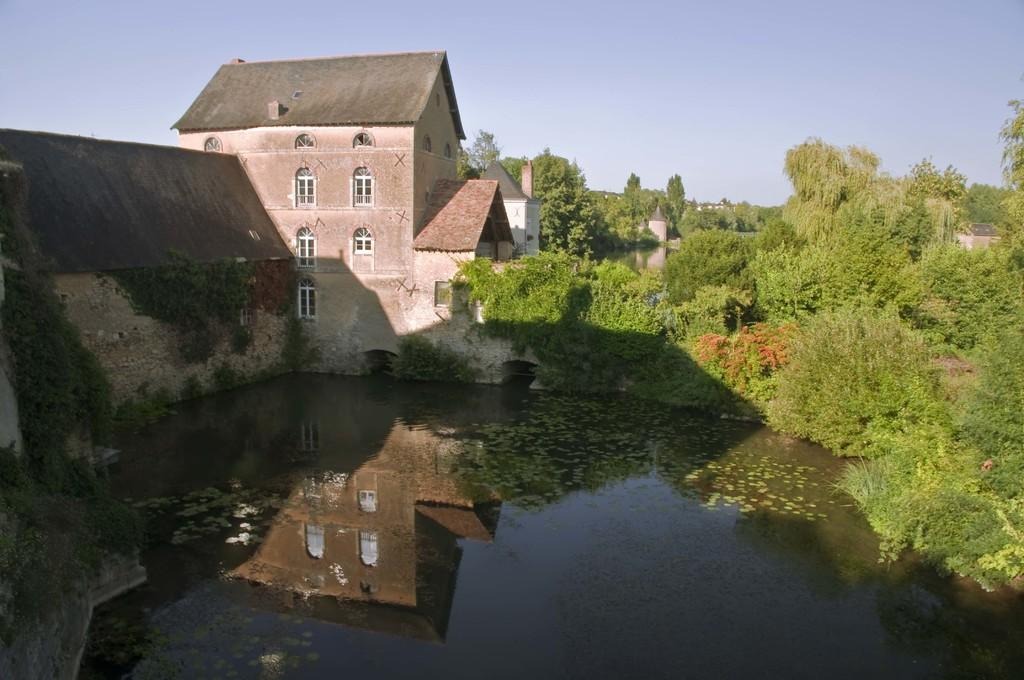What type of structure is present in the image? There is a building in the image. What feature of the building is mentioned in the facts? The building has windows. What natural elements can be seen in the image? There are trees, plants, and water visible in the image. What part of the sky is visible in the image? The sky is visible in the image. What additional detail about the building can be observed? The reflection of the building is visible on the water. How many parcels are being delivered to the building in the image? There is no mention of parcels or delivery in the image or the provided facts. 